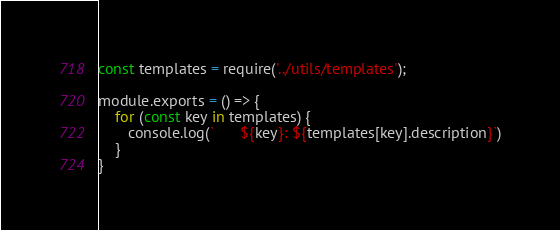Convert code to text. <code><loc_0><loc_0><loc_500><loc_500><_JavaScript_>const templates = require('../utils/templates');

module.exports = () => {
    for (const key in templates) {
       console.log(`      ${key}: ${templates[key].description}`)
    }
}</code> 